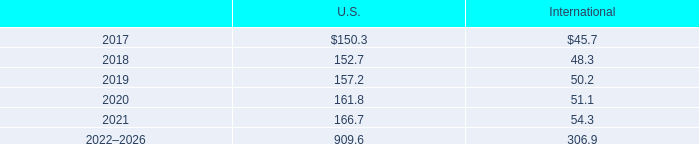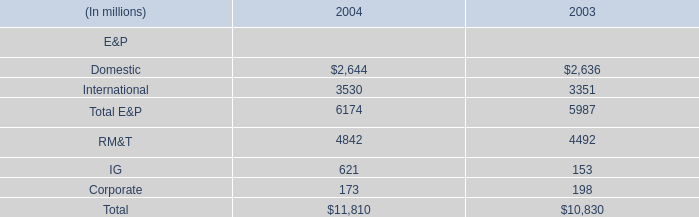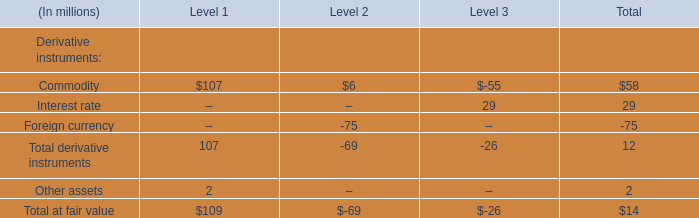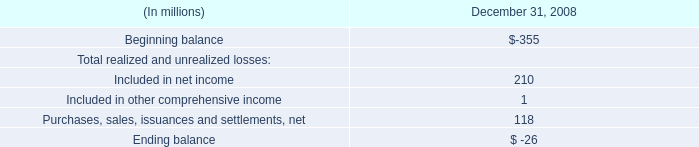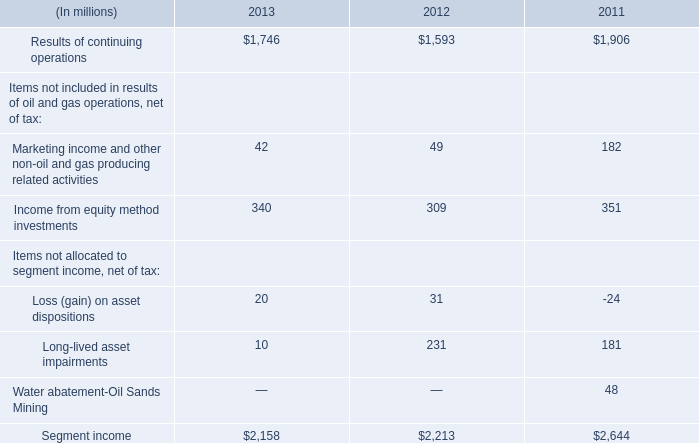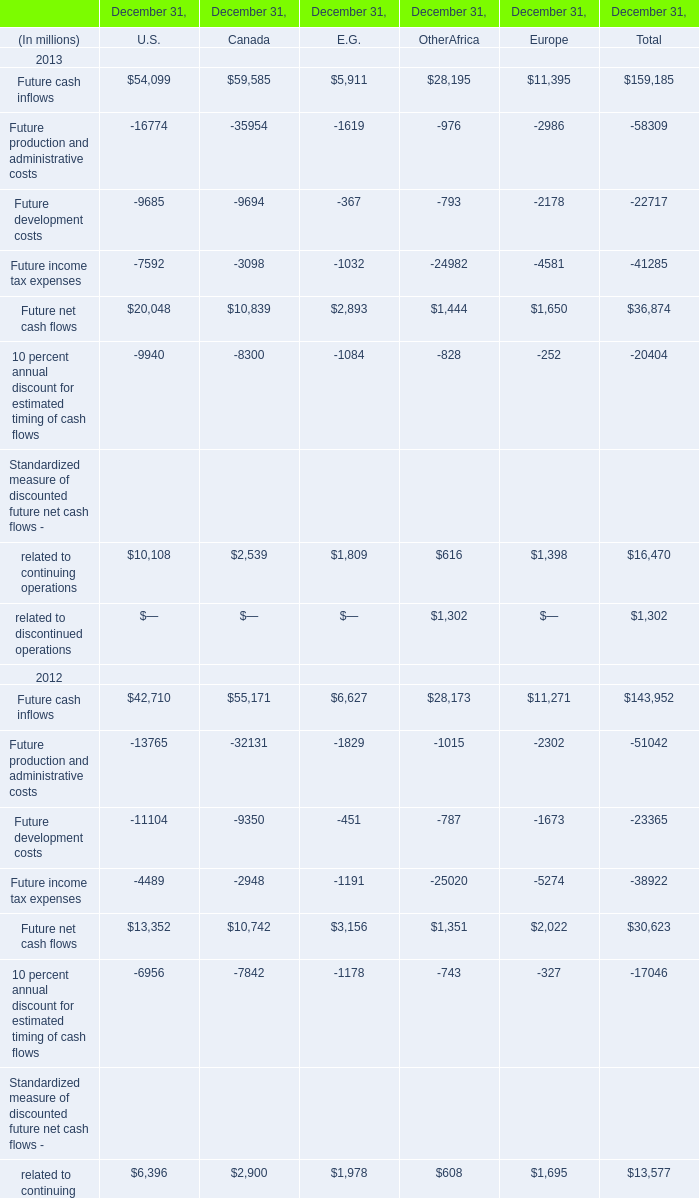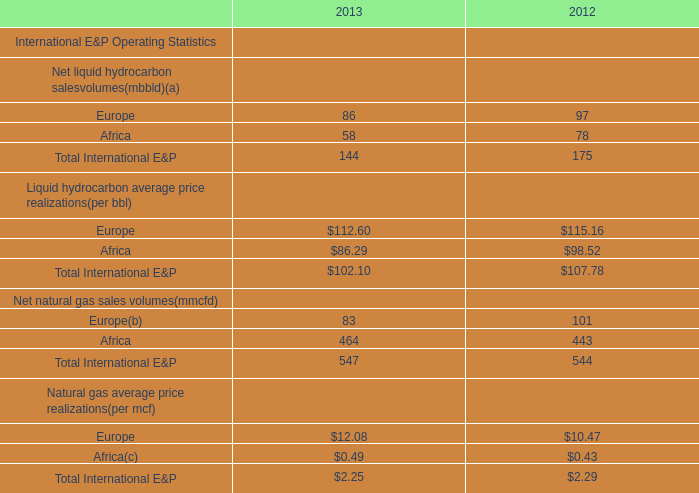If Income from equity method investments develops with the same increasing rate in 2013, what will it reach in 2014? (in million) 
Computations: (340 * (1 + ((340 - 309) / 309)))
Answer: 374.11003. 